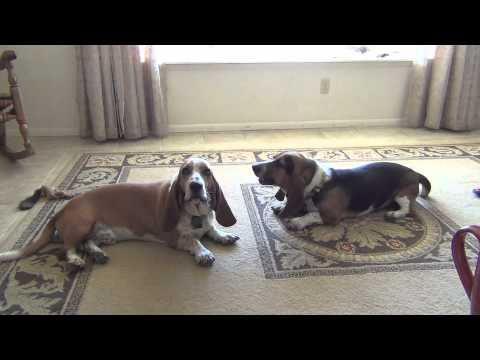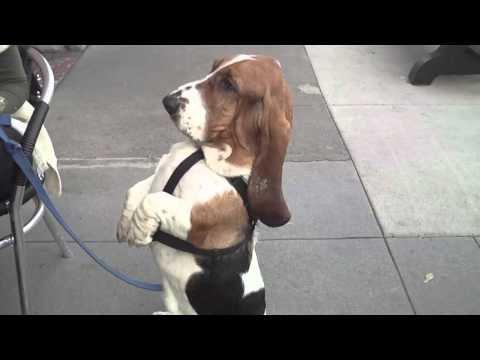The first image is the image on the left, the second image is the image on the right. Evaluate the accuracy of this statement regarding the images: "There is at least two dogs in the right image.". Is it true? Answer yes or no. No. The first image is the image on the left, the second image is the image on the right. For the images shown, is this caption "At least one of the dogs is lying down with its belly on the floor." true? Answer yes or no. Yes. 